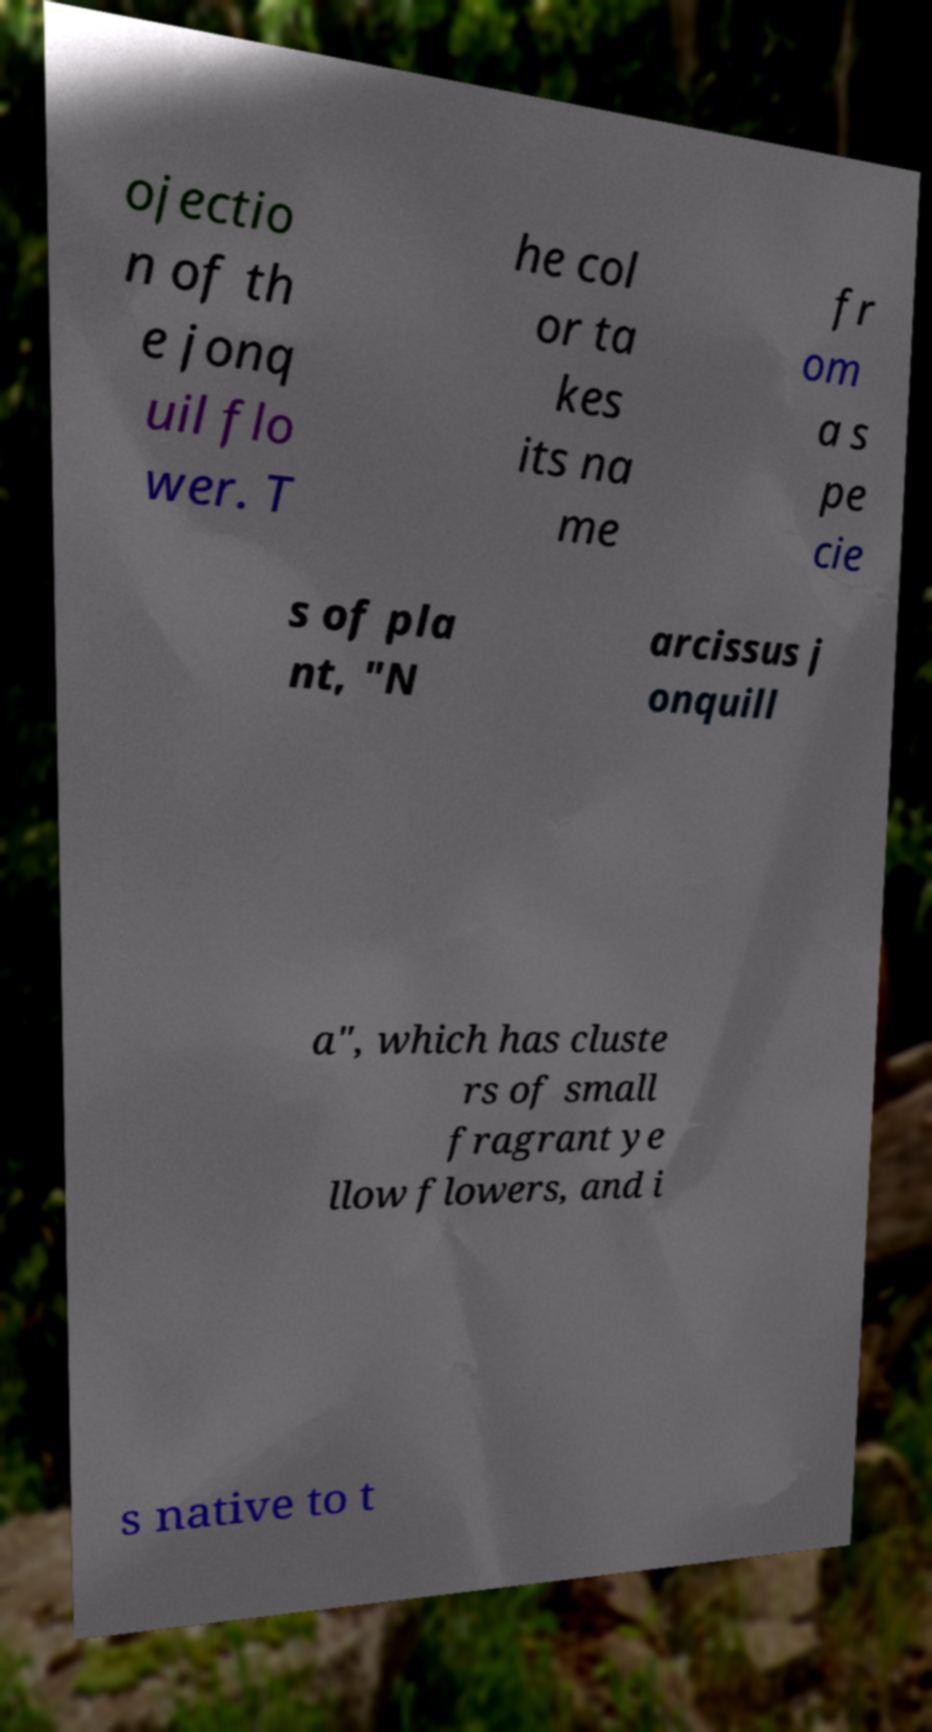Please read and relay the text visible in this image. What does it say? ojectio n of th e jonq uil flo wer. T he col or ta kes its na me fr om a s pe cie s of pla nt, "N arcissus j onquill a", which has cluste rs of small fragrant ye llow flowers, and i s native to t 